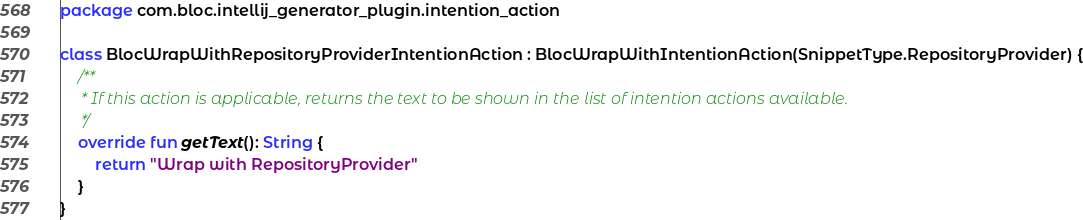<code> <loc_0><loc_0><loc_500><loc_500><_Kotlin_>package com.bloc.intellij_generator_plugin.intention_action

class BlocWrapWithRepositoryProviderIntentionAction : BlocWrapWithIntentionAction(SnippetType.RepositoryProvider) {
    /**
     * If this action is applicable, returns the text to be shown in the list of intention actions available.
     */
    override fun getText(): String {
        return "Wrap with RepositoryProvider"
    }
}</code> 